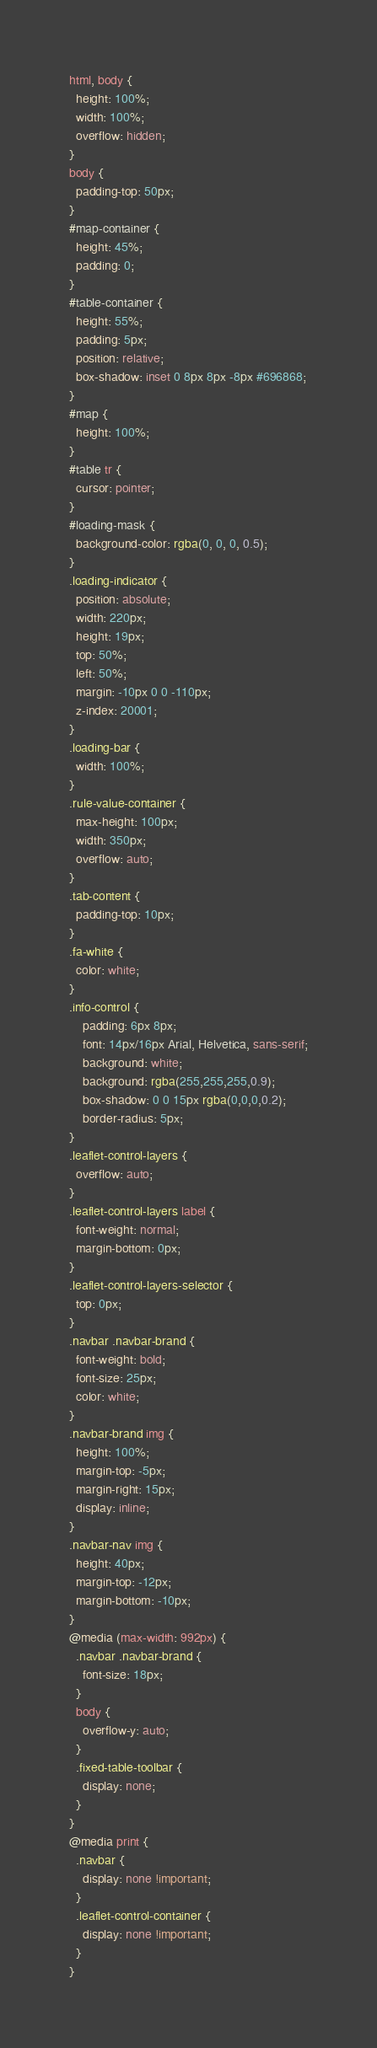Convert code to text. <code><loc_0><loc_0><loc_500><loc_500><_CSS_>html, body {
  height: 100%;
  width: 100%;
  overflow: hidden;
}
body {
  padding-top: 50px;
}
#map-container {
  height: 45%;
  padding: 0;
}
#table-container {
  height: 55%;
  padding: 5px;
  position: relative;
  box-shadow: inset 0 8px 8px -8px #696868;
}
#map {
  height: 100%;
}
#table tr {
  cursor: pointer;
}
#loading-mask {
  background-color: rgba(0, 0, 0, 0.5);
}
.loading-indicator {
  position: absolute;
  width: 220px;
  height: 19px;
  top: 50%;
  left: 50%;
  margin: -10px 0 0 -110px;
  z-index: 20001;
}
.loading-bar {
  width: 100%;
}
.rule-value-container {
  max-height: 100px;
  width: 350px;
  overflow: auto;
}
.tab-content {
  padding-top: 10px;
}
.fa-white {
  color: white;
}
.info-control {
	padding: 6px 8px;
	font: 14px/16px Arial, Helvetica, sans-serif;
	background: white;
	background: rgba(255,255,255,0.9);
	box-shadow: 0 0 15px rgba(0,0,0,0.2);
	border-radius: 5px;
}
.leaflet-control-layers {
  overflow: auto;
}
.leaflet-control-layers label {
  font-weight: normal;
  margin-bottom: 0px;
}
.leaflet-control-layers-selector {
  top: 0px;
}
.navbar .navbar-brand {
  font-weight: bold;
  font-size: 25px;
  color: white;
}
.navbar-brand img {
  height: 100%;
  margin-top: -5px;
  margin-right: 15px;
  display: inline;
}
.navbar-nav img {
  height: 40px;
  margin-top: -12px;
  margin-bottom: -10px;
}
@media (max-width: 992px) {
  .navbar .navbar-brand {
    font-size: 18px;
  }
  body {
    overflow-y: auto;
  }
  .fixed-table-toolbar {
    display: none;
  }
}
@media print {
  .navbar {
    display: none !important;
  }
  .leaflet-control-container {
    display: none !important;
  }
}
</code> 